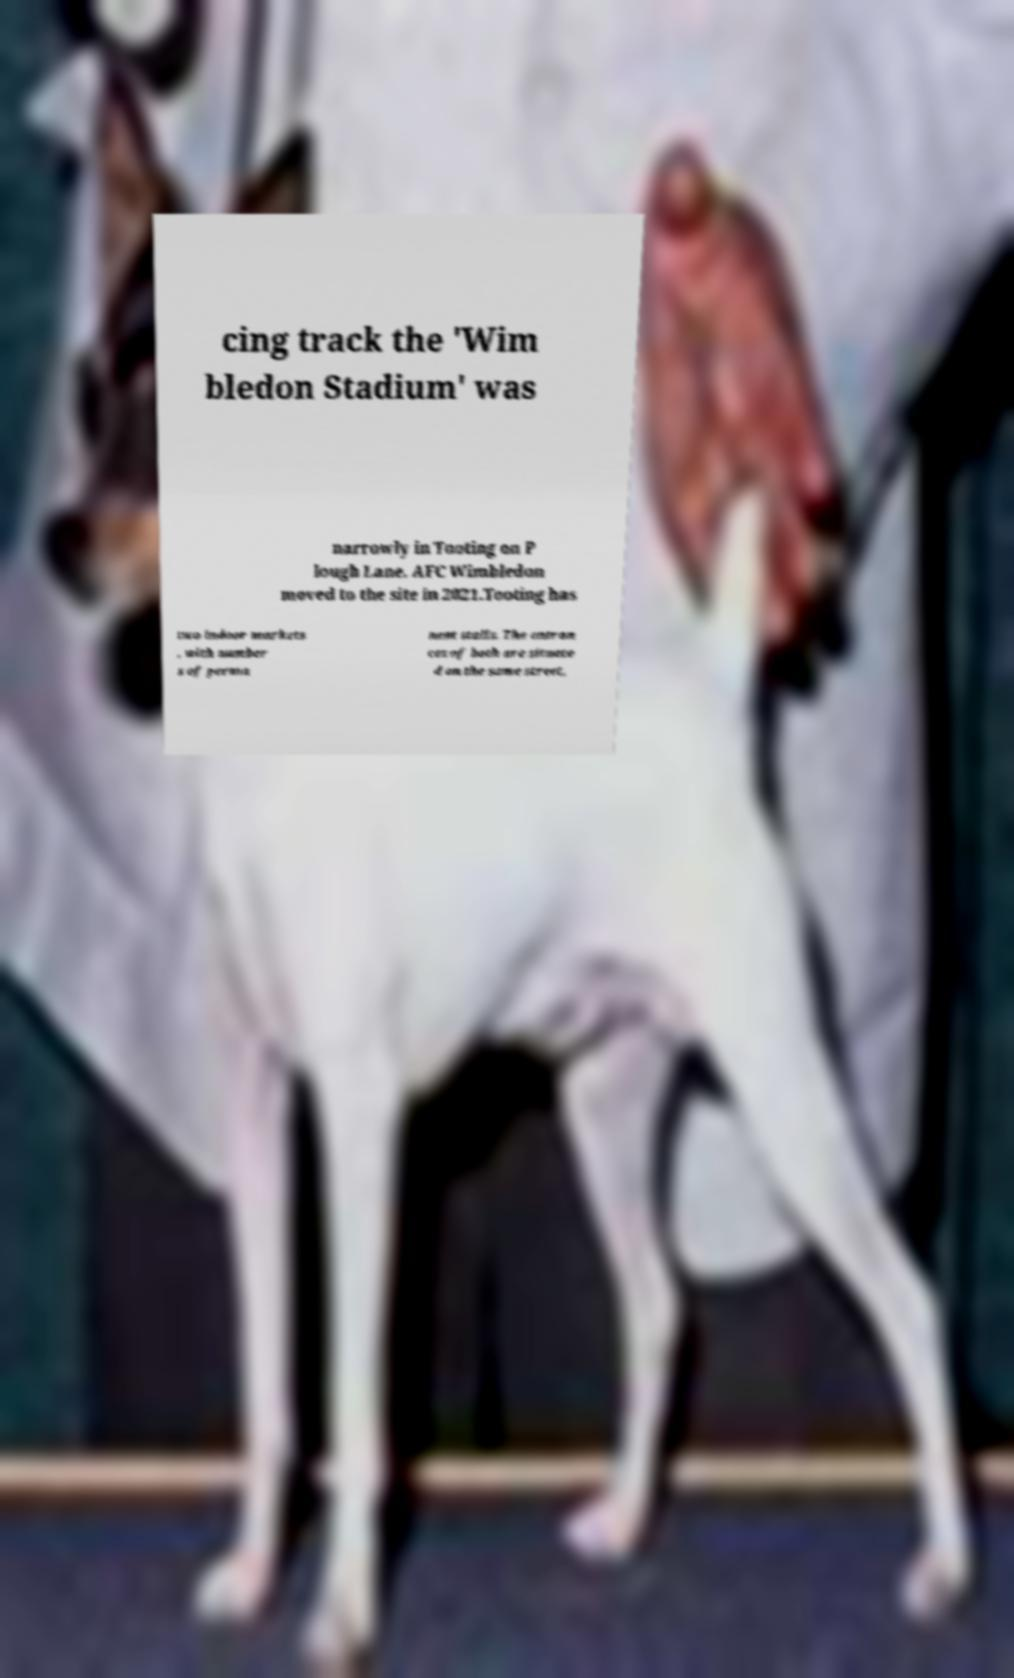Could you assist in decoding the text presented in this image and type it out clearly? cing track the 'Wim bledon Stadium' was narrowly in Tooting on P lough Lane. AFC Wimbledon moved to the site in 2021.Tooting has two indoor markets , with number s of perma nent stalls. The entran ces of both are situate d on the same street, 